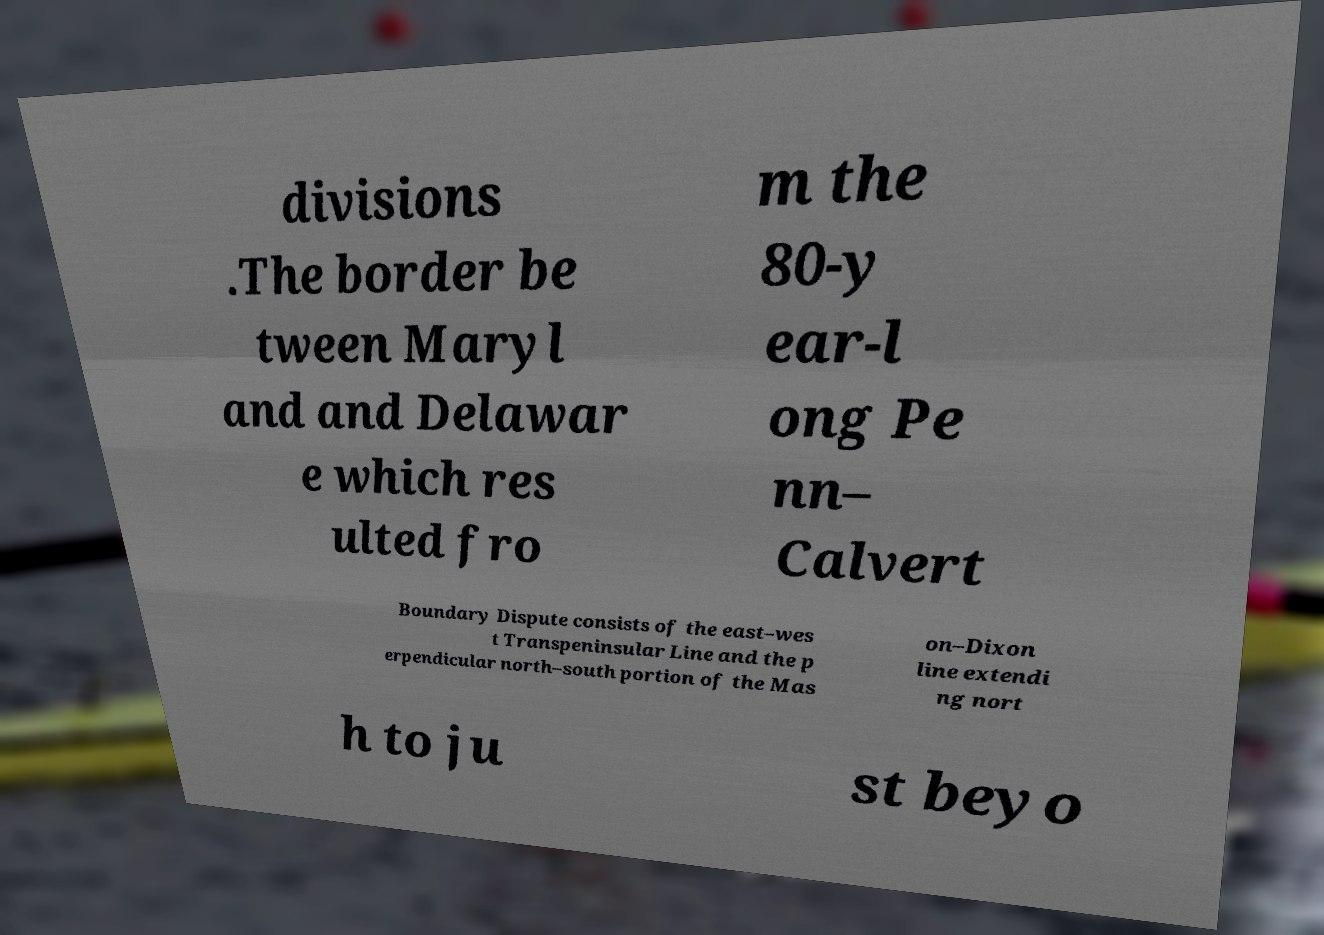There's text embedded in this image that I need extracted. Can you transcribe it verbatim? divisions .The border be tween Maryl and and Delawar e which res ulted fro m the 80-y ear-l ong Pe nn– Calvert Boundary Dispute consists of the east–wes t Transpeninsular Line and the p erpendicular north–south portion of the Mas on–Dixon line extendi ng nort h to ju st beyo 